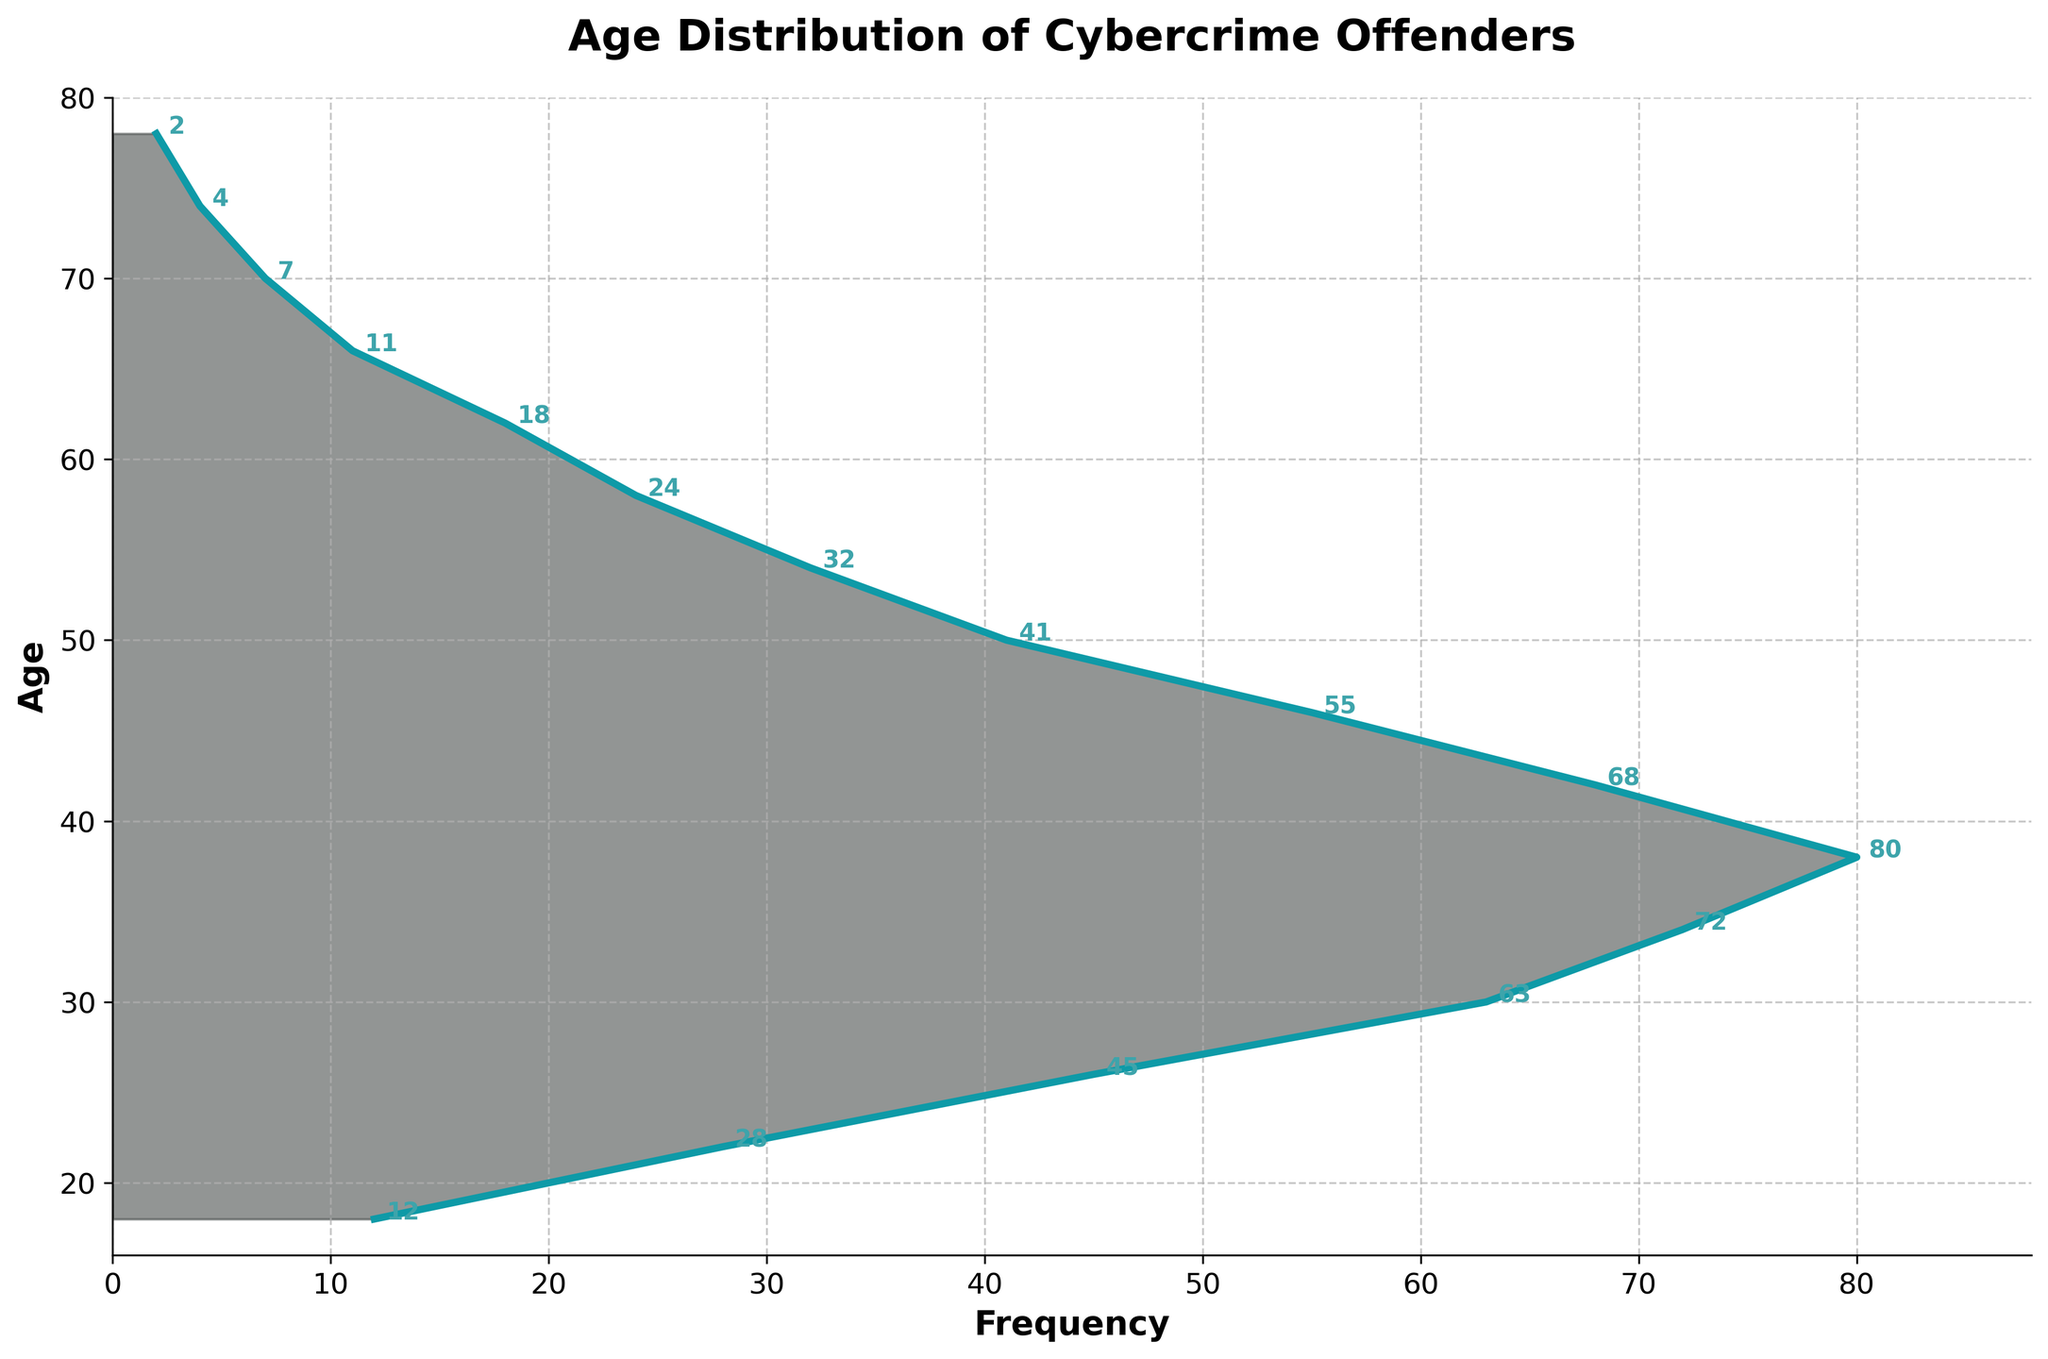What is the age range shown in the plot? The axis for age ranges from 18 to 78. Therefore, the ages span from the minimum value of 18 to the maximum value of 78.
Answer: 18 to 78 What is the most common age group for cybercrime offenders? Look for the age with the highest frequency, which corresponds to the peak of the density plot. The highest frequency, 80, occurs at age 38.
Answer: 38 How does the number of offenders change from age 30 to 34? The frequency at age 30 is 63, and at age 34 it is 72. The number of offenders increases by 72 - 63 = 9.
Answer: Increases by 9 Which age group has the fewest cybercrime offenders and what is their frequency? The age with the lowest frequency is the point with the smallest value on the frequency axis. The lowest frequency, 2, occurs at age 78.
Answer: 78, with a frequency of 2 Between which ages does the frequency of cybercrime offenders start to decline significantly? Observe the trend of the plot. The frequency starts to decline significantly after the peak at age 38, starting to drop off noticeably at age 42.
Answer: After age 38 At which ages are the frequencies equal to 24? Look for the ages where the frequency value equals 24. In the plot, frequencies of 24 occur at ages 22 and 58.
Answer: 58 Calculate the average frequency of offenders aged between 18 and 30. Sum the frequencies for ages 18, 22, 26, and 30, then divide by the number of age groups: (12 + 28 + 45 + 63) / 4 = 37
Answer: 37 Which age group shows a similar frequency to age 50? Identify the frequency of age 50, which is 41, and find the nearest values. Age 54 has a frequency of 32, which is the closest.
Answer: Age 54 Is there an age where the frequency of offenders is exactly half of the most common age group? The most common age group is at age 38 with a frequency of 80. Half of 80 is 40. The frequency closest to 40 is at age 50, where it is 41.
Answer: Age 50 How many age groups have frequencies greater than 60? Count the ages where the frequencies exceed 60: Ages 34, 38, and 42, which sums up to 3 age groups.
Answer: 3 